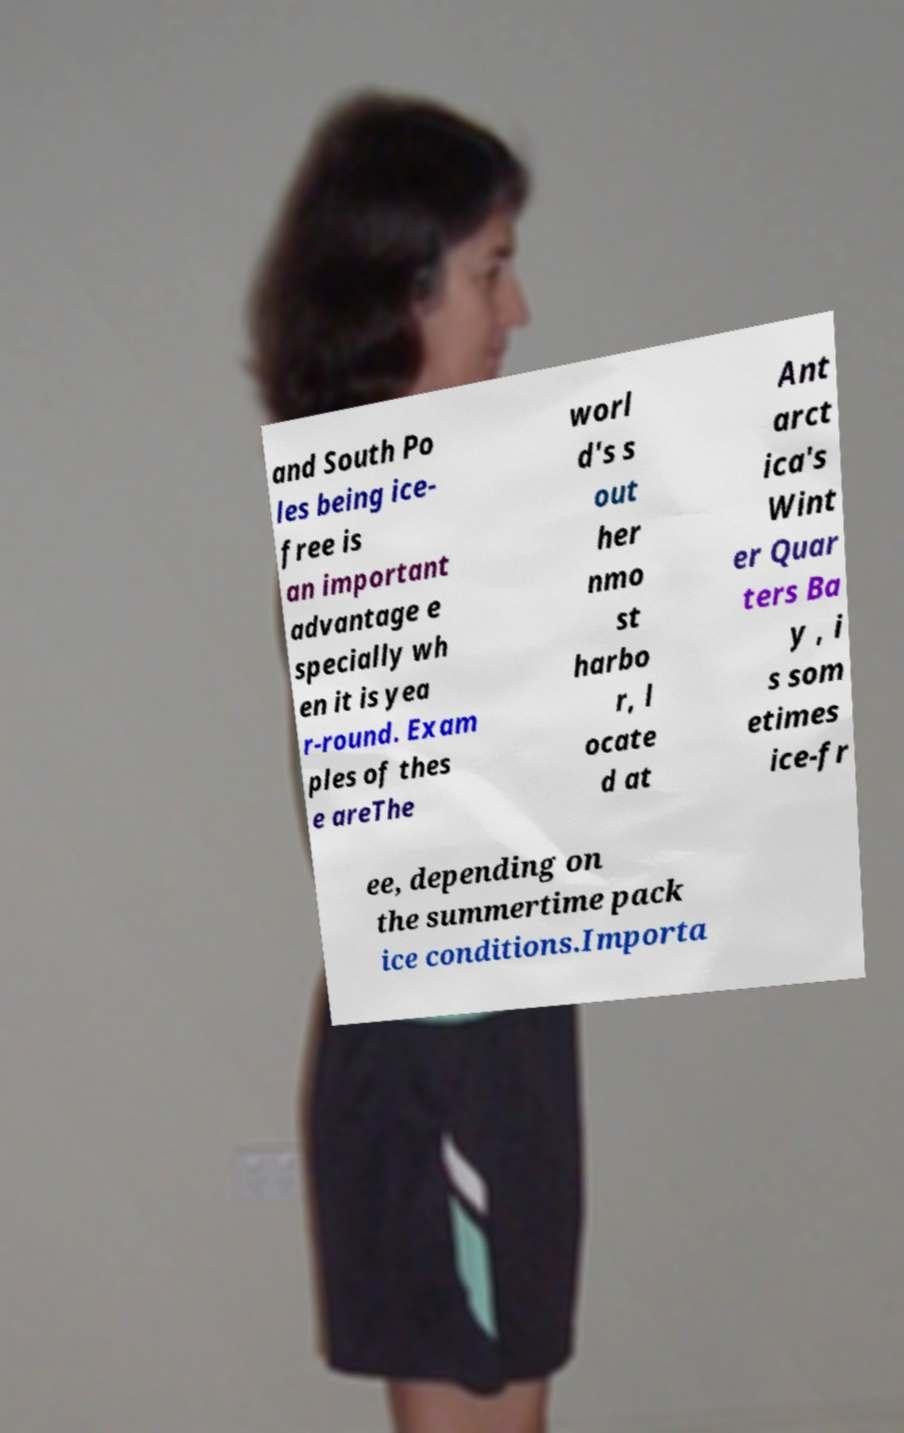Can you read and provide the text displayed in the image?This photo seems to have some interesting text. Can you extract and type it out for me? and South Po les being ice- free is an important advantage e specially wh en it is yea r-round. Exam ples of thes e areThe worl d's s out her nmo st harbo r, l ocate d at Ant arct ica's Wint er Quar ters Ba y , i s som etimes ice-fr ee, depending on the summertime pack ice conditions.Importa 